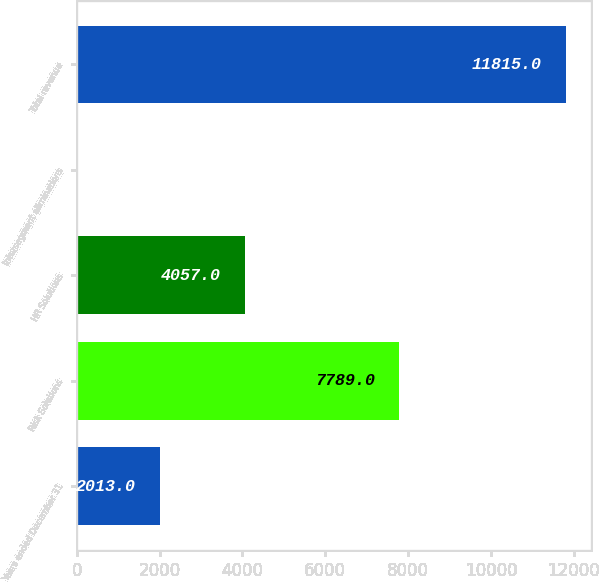<chart> <loc_0><loc_0><loc_500><loc_500><bar_chart><fcel>Years ended December 31<fcel>Risk Solutions<fcel>HR Solutions<fcel>Intersegment eliminations<fcel>Total revenue<nl><fcel>2013<fcel>7789<fcel>4057<fcel>31<fcel>11815<nl></chart> 